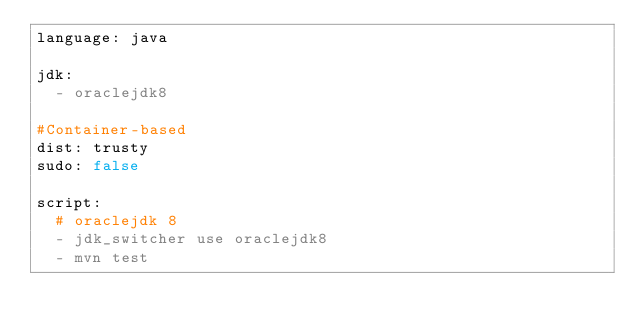<code> <loc_0><loc_0><loc_500><loc_500><_YAML_>language: java

jdk:
  - oraclejdk8

#Container-based
dist: trusty
sudo: false

script:
  # oraclejdk 8
  - jdk_switcher use oraclejdk8
  - mvn test</code> 